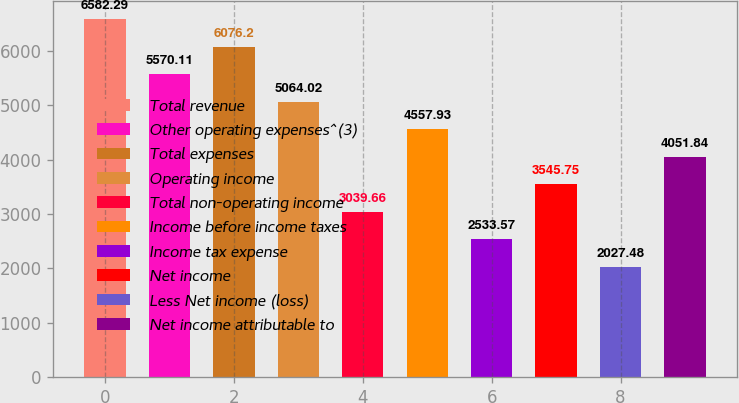Convert chart to OTSL. <chart><loc_0><loc_0><loc_500><loc_500><bar_chart><fcel>Total revenue<fcel>Other operating expenses^(3)<fcel>Total expenses<fcel>Operating income<fcel>Total non-operating income<fcel>Income before income taxes<fcel>Income tax expense<fcel>Net income<fcel>Less Net income (loss)<fcel>Net income attributable to<nl><fcel>6582.29<fcel>5570.11<fcel>6076.2<fcel>5064.02<fcel>3039.66<fcel>4557.93<fcel>2533.57<fcel>3545.75<fcel>2027.48<fcel>4051.84<nl></chart> 